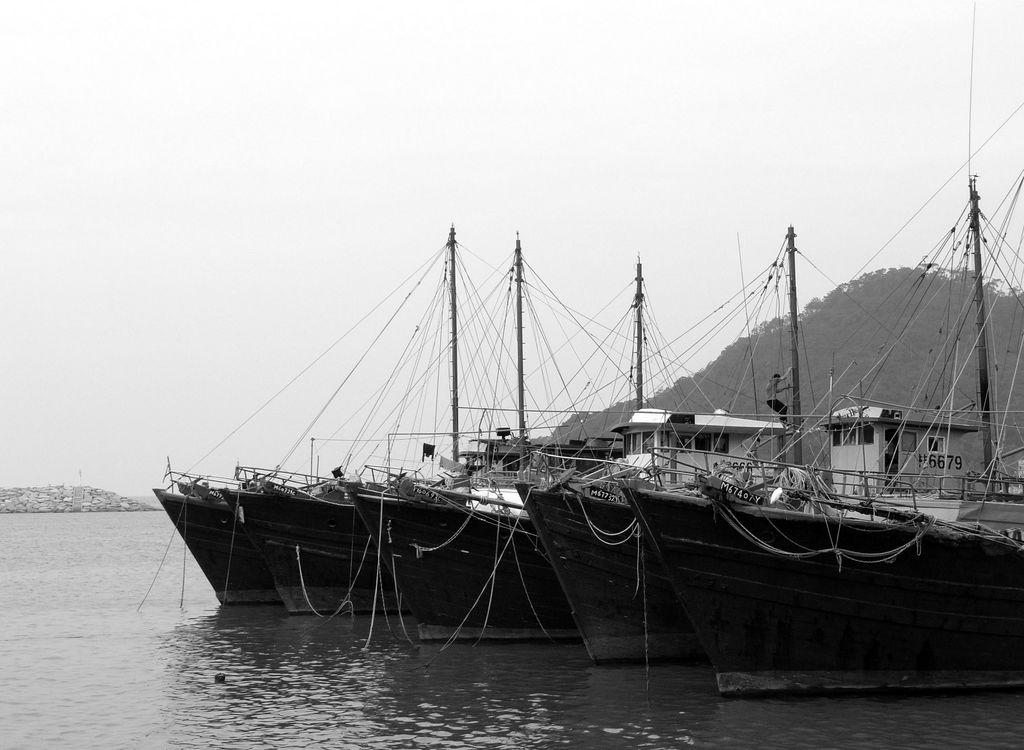What is the color scheme of the image? The image is black and white. What type of vehicles can be seen in the image? There are ships in the image. What type of structures are present in the image? There are sheds in the image. What type of natural elements can be seen in the image? There are stones, a hill, trees, water, and sky in the image. How many eggs are visible in the image? There are no eggs present in the image. What type of line can be seen connecting the hill and the water in the image? There is no line connecting the hill and the water in the image. 